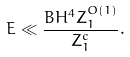Convert formula to latex. <formula><loc_0><loc_0><loc_500><loc_500>E \ll \frac { B H ^ { 4 } Z _ { 1 } ^ { O ( 1 ) } } { Z _ { 1 } ^ { c } } .</formula> 